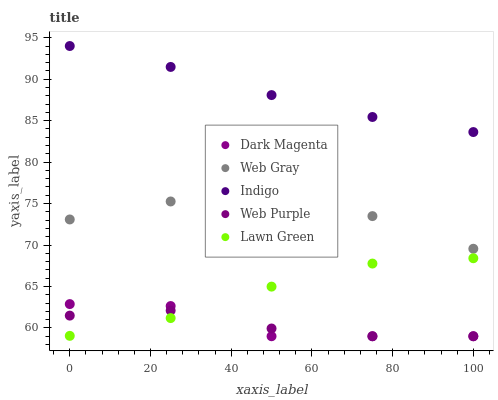Does Web Purple have the minimum area under the curve?
Answer yes or no. Yes. Does Indigo have the maximum area under the curve?
Answer yes or no. Yes. Does Web Gray have the minimum area under the curve?
Answer yes or no. No. Does Web Gray have the maximum area under the curve?
Answer yes or no. No. Is Indigo the smoothest?
Answer yes or no. Yes. Is Dark Magenta the roughest?
Answer yes or no. Yes. Is Web Purple the smoothest?
Answer yes or no. No. Is Web Purple the roughest?
Answer yes or no. No. Does Web Purple have the lowest value?
Answer yes or no. Yes. Does Web Gray have the lowest value?
Answer yes or no. No. Does Indigo have the highest value?
Answer yes or no. Yes. Does Web Gray have the highest value?
Answer yes or no. No. Is Web Gray less than Indigo?
Answer yes or no. Yes. Is Indigo greater than Web Purple?
Answer yes or no. Yes. Does Web Purple intersect Lawn Green?
Answer yes or no. Yes. Is Web Purple less than Lawn Green?
Answer yes or no. No. Is Web Purple greater than Lawn Green?
Answer yes or no. No. Does Web Gray intersect Indigo?
Answer yes or no. No. 